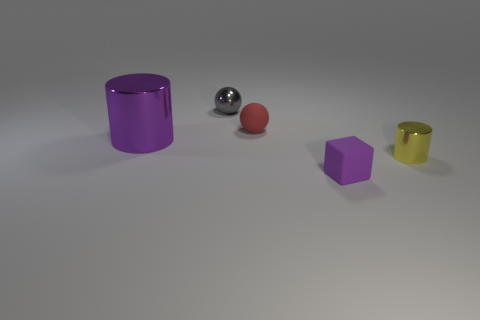Are the small red ball and the purple object right of the red object made of the same material?
Keep it short and to the point. Yes. There is another object that is the same color as the big shiny object; what material is it?
Your response must be concise. Rubber. Is the shape of the big purple metallic object the same as the metal object that is right of the small rubber cube?
Keep it short and to the point. Yes. The object that is the same material as the tiny red ball is what color?
Offer a very short reply. Purple. There is a object to the right of the cube; what size is it?
Provide a short and direct response. Small. Is the color of the rubber block the same as the large shiny object?
Give a very brief answer. Yes. What is the color of the small rubber sphere right of the tiny metallic thing behind the red sphere?
Give a very brief answer. Red. The cylinder that is to the right of the matte object that is in front of the cylinder to the right of the purple shiny cylinder is made of what material?
Offer a very short reply. Metal. There is a shiny cylinder that is right of the rubber block; is it the same size as the tiny gray ball?
Give a very brief answer. Yes. There is a ball that is in front of the gray thing; what material is it?
Provide a succinct answer. Rubber. 